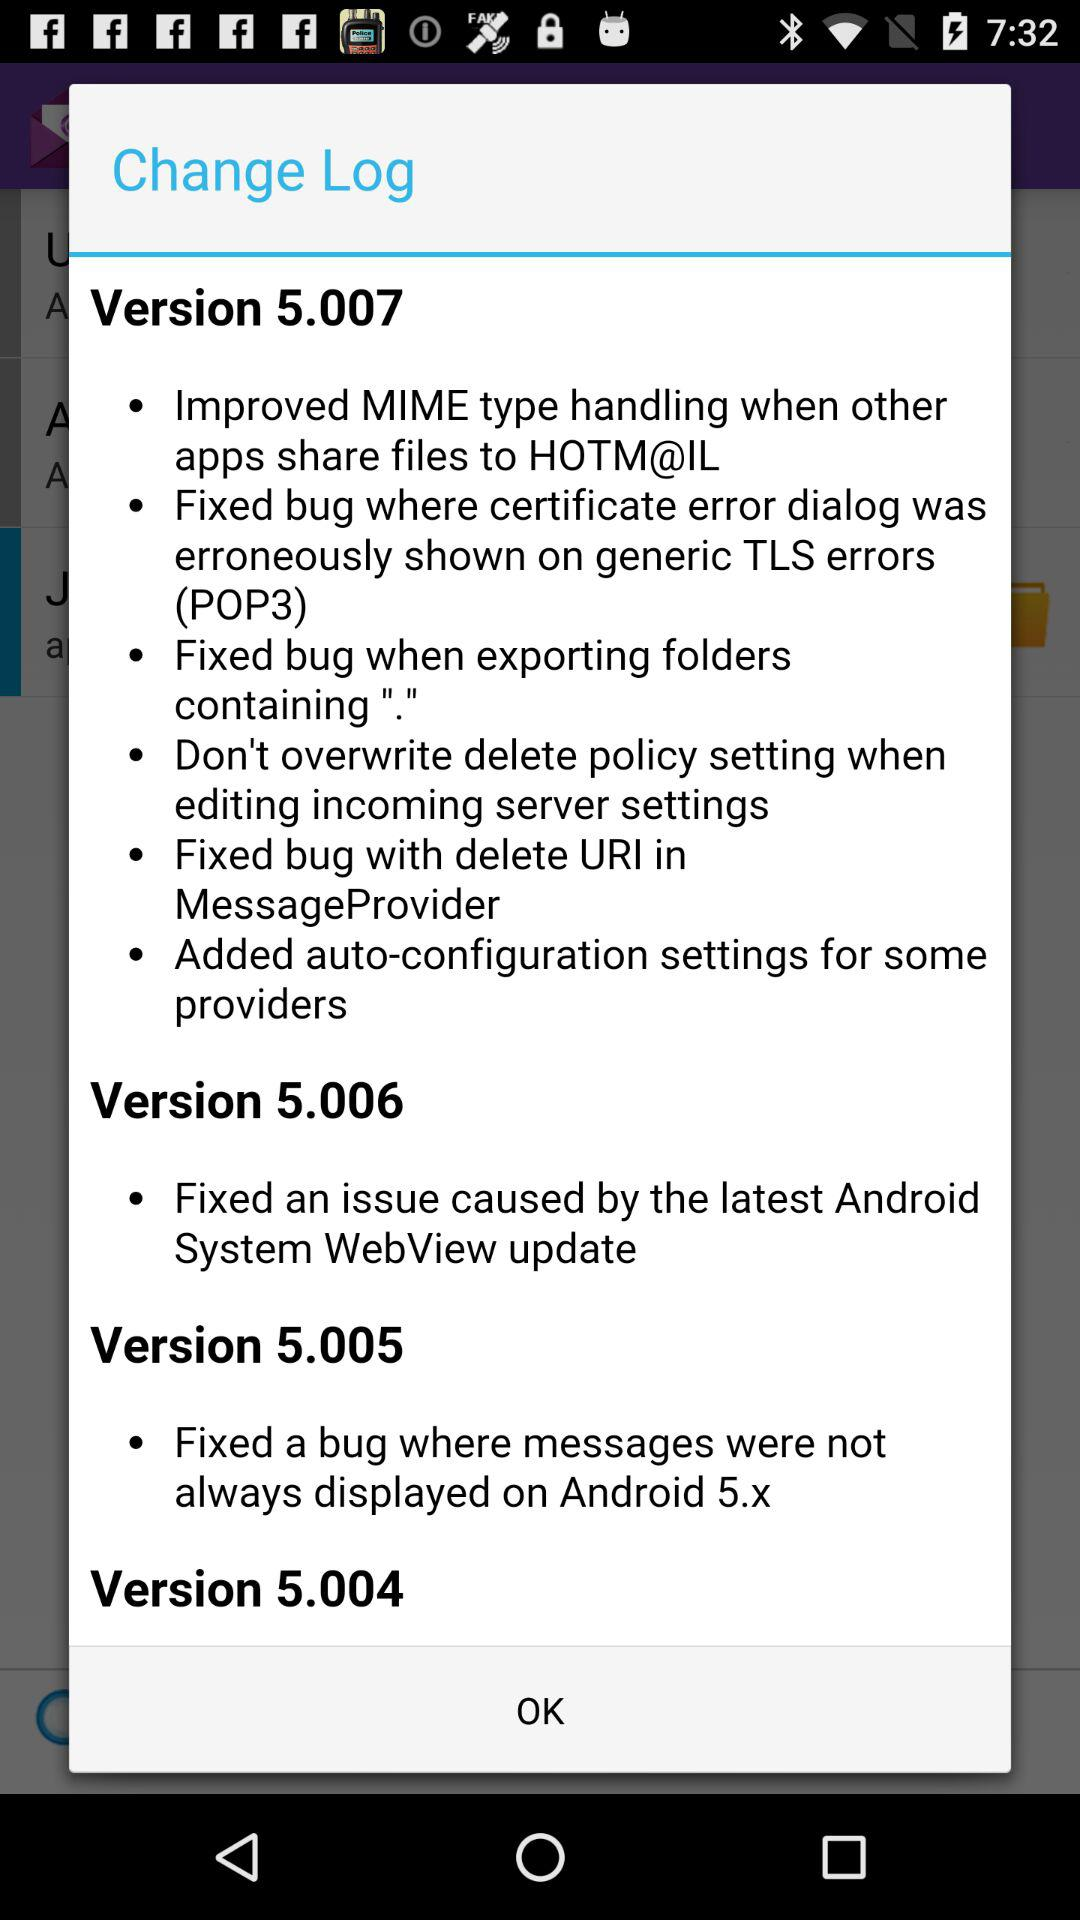Which version improved MIME? The version that improved MIME is 5.007. 